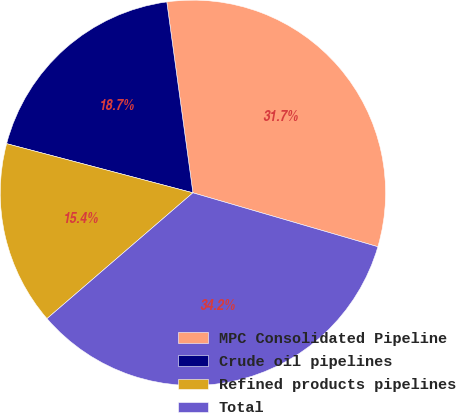Convert chart. <chart><loc_0><loc_0><loc_500><loc_500><pie_chart><fcel>MPC Consolidated Pipeline<fcel>Crude oil pipelines<fcel>Refined products pipelines<fcel>Total<nl><fcel>31.68%<fcel>18.73%<fcel>15.43%<fcel>34.16%<nl></chart> 